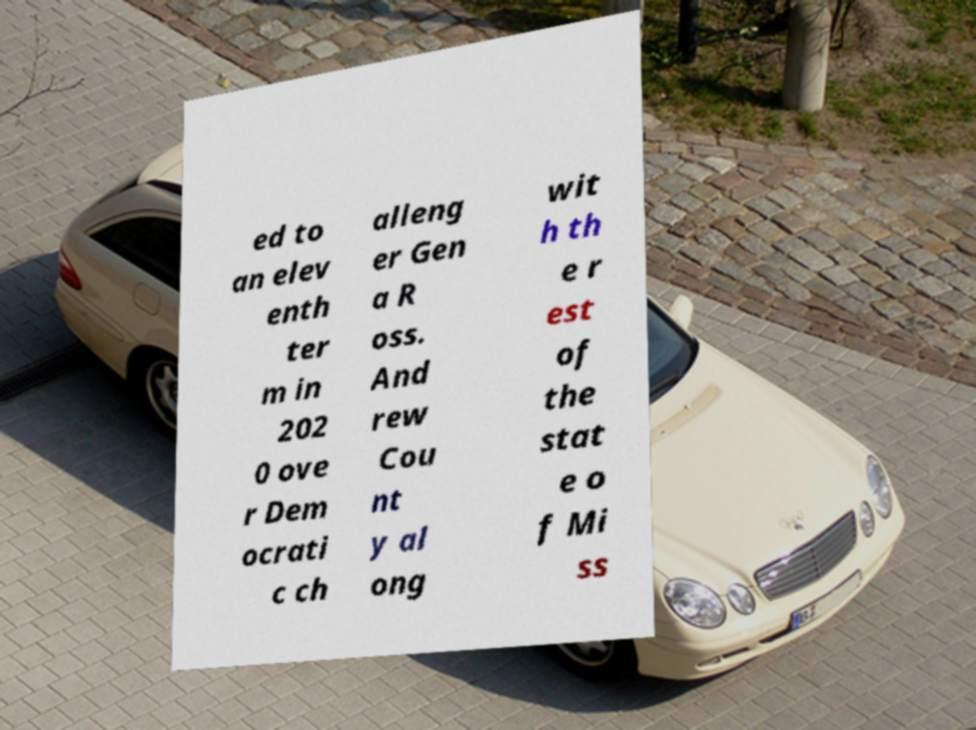Please identify and transcribe the text found in this image. ed to an elev enth ter m in 202 0 ove r Dem ocrati c ch alleng er Gen a R oss. And rew Cou nt y al ong wit h th e r est of the stat e o f Mi ss 